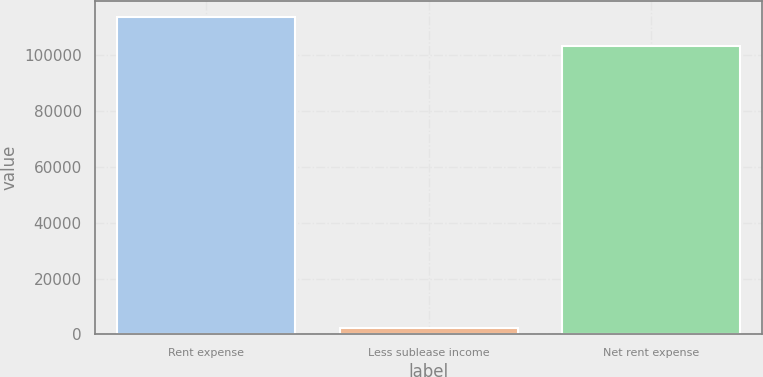Convert chart. <chart><loc_0><loc_0><loc_500><loc_500><bar_chart><fcel>Rent expense<fcel>Less sublease income<fcel>Net rent expense<nl><fcel>113827<fcel>2330<fcel>103479<nl></chart> 